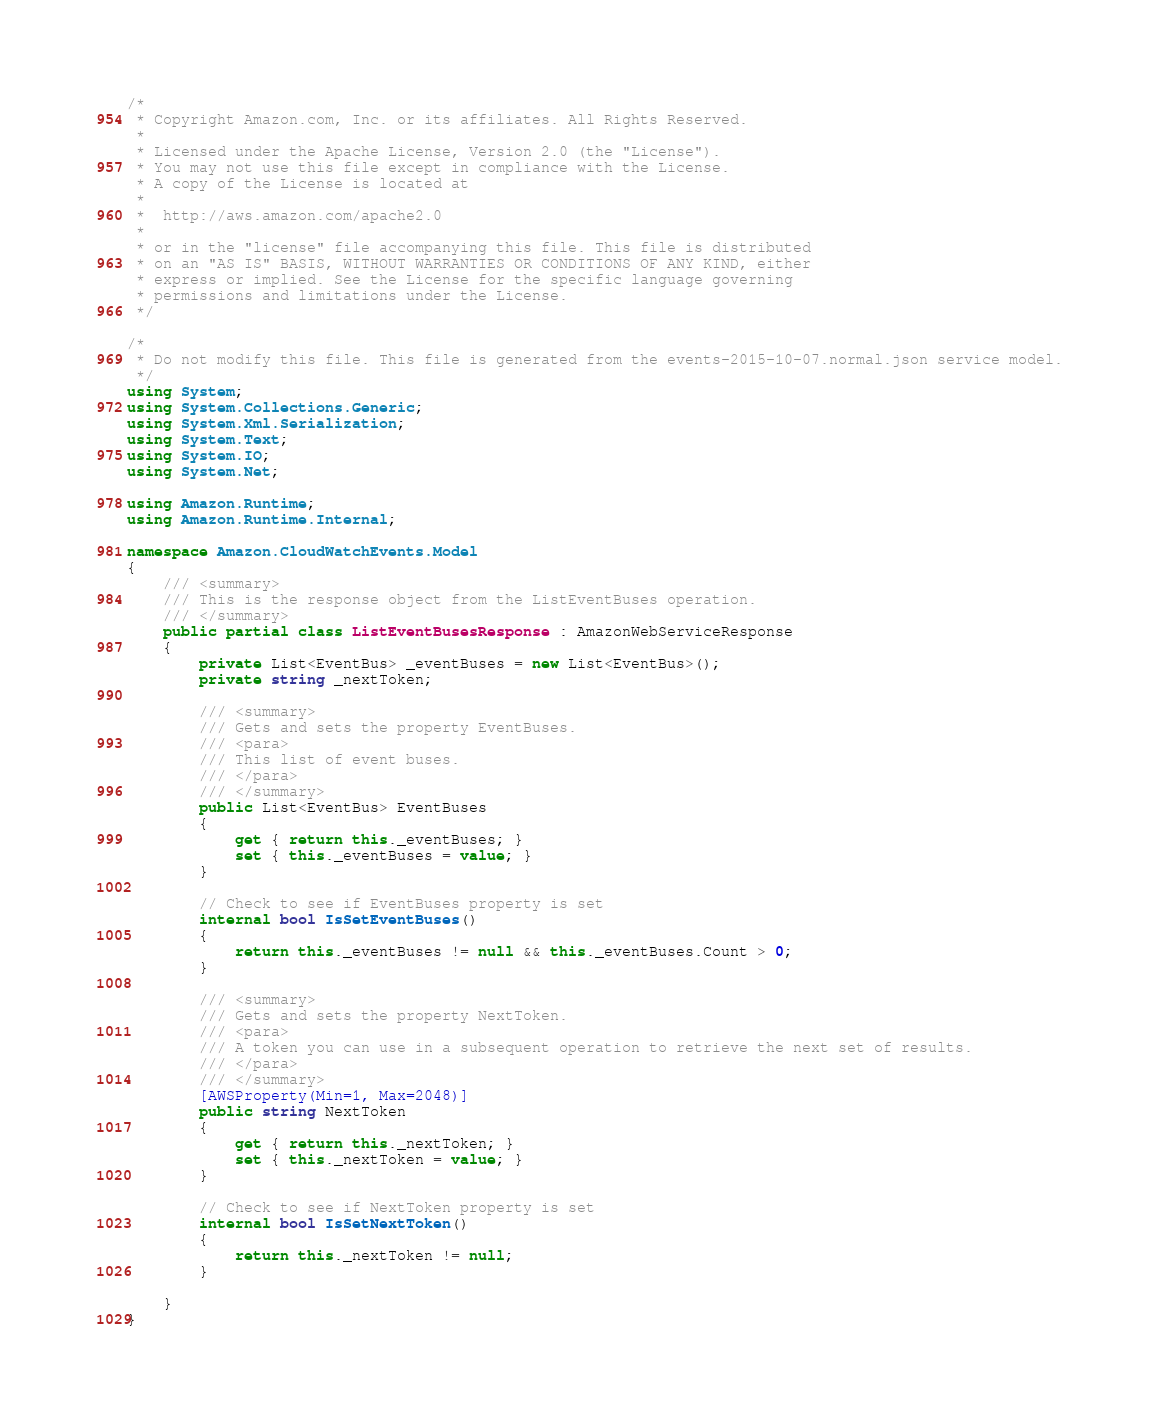Convert code to text. <code><loc_0><loc_0><loc_500><loc_500><_C#_>/*
 * Copyright Amazon.com, Inc. or its affiliates. All Rights Reserved.
 * 
 * Licensed under the Apache License, Version 2.0 (the "License").
 * You may not use this file except in compliance with the License.
 * A copy of the License is located at
 * 
 *  http://aws.amazon.com/apache2.0
 * 
 * or in the "license" file accompanying this file. This file is distributed
 * on an "AS IS" BASIS, WITHOUT WARRANTIES OR CONDITIONS OF ANY KIND, either
 * express or implied. See the License for the specific language governing
 * permissions and limitations under the License.
 */

/*
 * Do not modify this file. This file is generated from the events-2015-10-07.normal.json service model.
 */
using System;
using System.Collections.Generic;
using System.Xml.Serialization;
using System.Text;
using System.IO;
using System.Net;

using Amazon.Runtime;
using Amazon.Runtime.Internal;

namespace Amazon.CloudWatchEvents.Model
{
    /// <summary>
    /// This is the response object from the ListEventBuses operation.
    /// </summary>
    public partial class ListEventBusesResponse : AmazonWebServiceResponse
    {
        private List<EventBus> _eventBuses = new List<EventBus>();
        private string _nextToken;

        /// <summary>
        /// Gets and sets the property EventBuses. 
        /// <para>
        /// This list of event buses.
        /// </para>
        /// </summary>
        public List<EventBus> EventBuses
        {
            get { return this._eventBuses; }
            set { this._eventBuses = value; }
        }

        // Check to see if EventBuses property is set
        internal bool IsSetEventBuses()
        {
            return this._eventBuses != null && this._eventBuses.Count > 0; 
        }

        /// <summary>
        /// Gets and sets the property NextToken. 
        /// <para>
        /// A token you can use in a subsequent operation to retrieve the next set of results.
        /// </para>
        /// </summary>
        [AWSProperty(Min=1, Max=2048)]
        public string NextToken
        {
            get { return this._nextToken; }
            set { this._nextToken = value; }
        }

        // Check to see if NextToken property is set
        internal bool IsSetNextToken()
        {
            return this._nextToken != null;
        }

    }
}</code> 